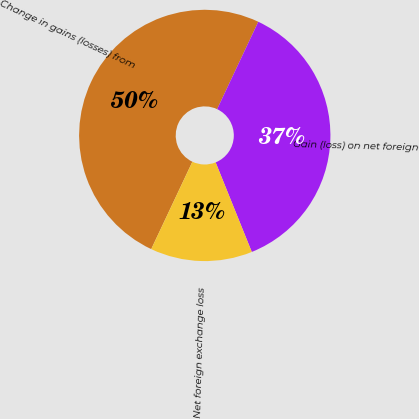Convert chart to OTSL. <chart><loc_0><loc_0><loc_500><loc_500><pie_chart><fcel>Change in gains (losses) from<fcel>Gain (loss) on net foreign<fcel>Net foreign exchange loss<nl><fcel>50.0%<fcel>36.89%<fcel>13.11%<nl></chart> 